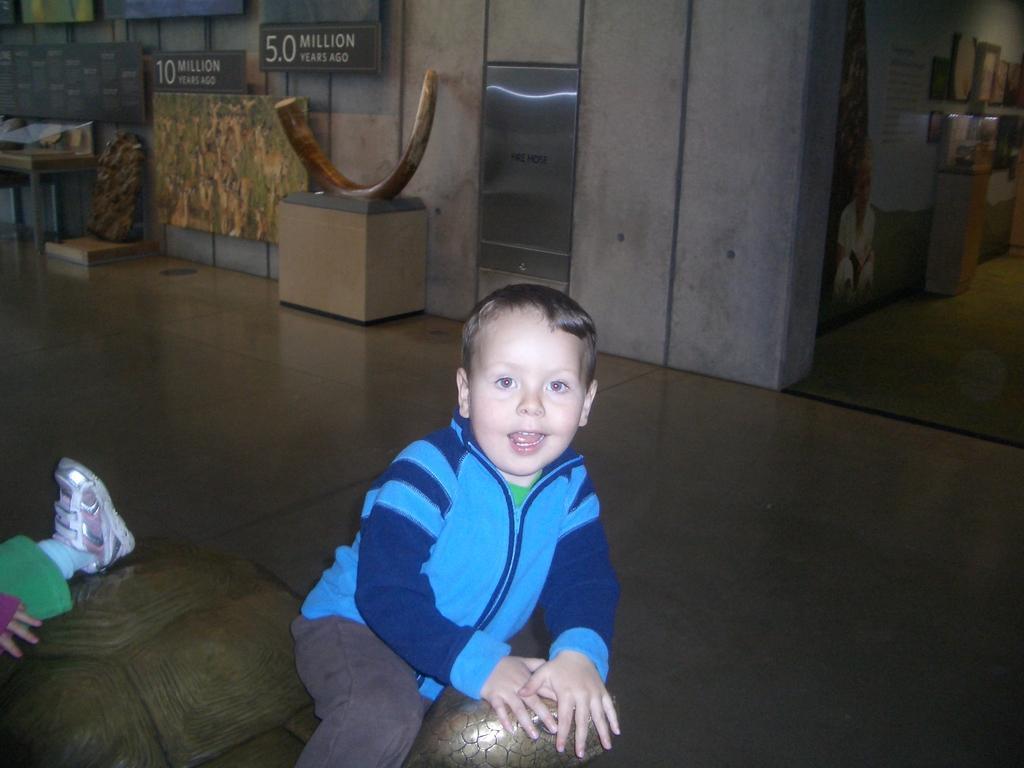Please provide a concise description of this image. This image is taken inside a room. In the middle of the image there is a boy sitting on a toy tortoise. In the left side of the image there is a man. At the bottom of the image there is a floor. At the background there is a wall with boards and a text on it. 